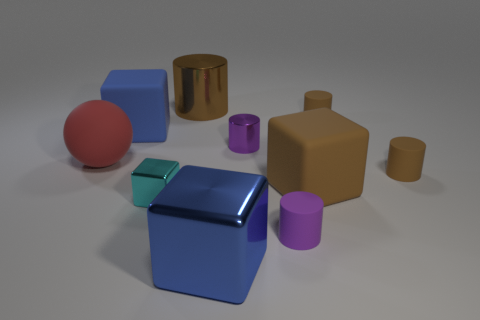What is the size of the matte block that is the same color as the large shiny cylinder?
Keep it short and to the point. Large. The big rubber thing that is the same color as the big cylinder is what shape?
Provide a short and direct response. Cube. What number of purple things are the same size as the purple metallic cylinder?
Your answer should be compact. 1. There is a large brown object in front of the big cylinder; is there a large blue metallic thing that is on the right side of it?
Ensure brevity in your answer.  No. What number of things are green cylinders or large brown cylinders?
Make the answer very short. 1. What color is the matte cube to the right of the rubber cylinder that is in front of the rubber cube that is to the right of the large brown cylinder?
Provide a succinct answer. Brown. Is there anything else of the same color as the sphere?
Offer a very short reply. No. Is the size of the blue rubber object the same as the purple shiny cylinder?
Provide a short and direct response. No. How many things are big things in front of the large red ball or small brown rubber cylinders behind the purple shiny cylinder?
Offer a very short reply. 3. What is the material of the small brown cylinder behind the large blue block that is behind the blue shiny block?
Provide a short and direct response. Rubber. 